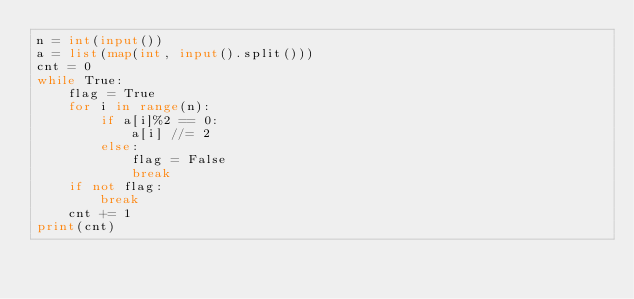<code> <loc_0><loc_0><loc_500><loc_500><_Python_>n = int(input())
a = list(map(int, input().split()))
cnt = 0
while True:
    flag = True
    for i in range(n):
        if a[i]%2 == 0:
            a[i] //= 2
        else:
            flag = False
            break
    if not flag:
        break
    cnt += 1
print(cnt)</code> 